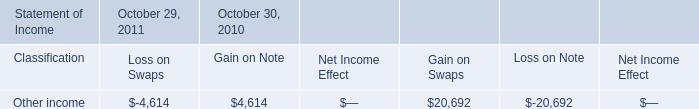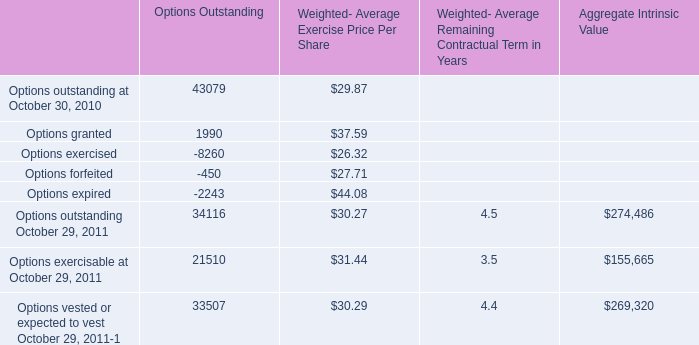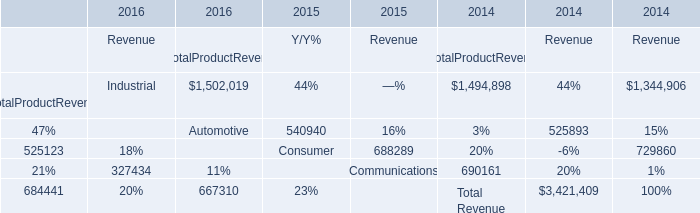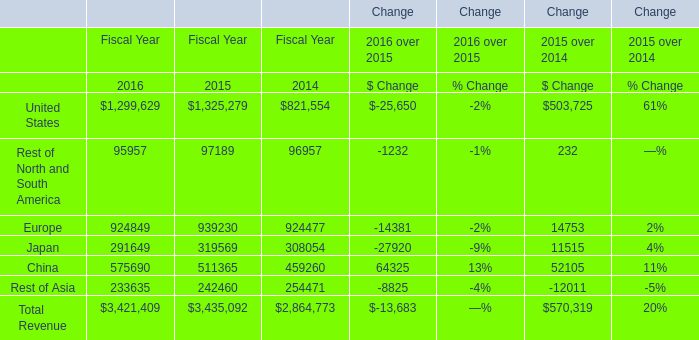What's the average of Other income of October 30, 2010 Gain on Swaps, and United States of Change Fiscal Year 2015 ? 
Computations: ((20692.0 + 1325279.0) / 2)
Answer: 672985.5. 